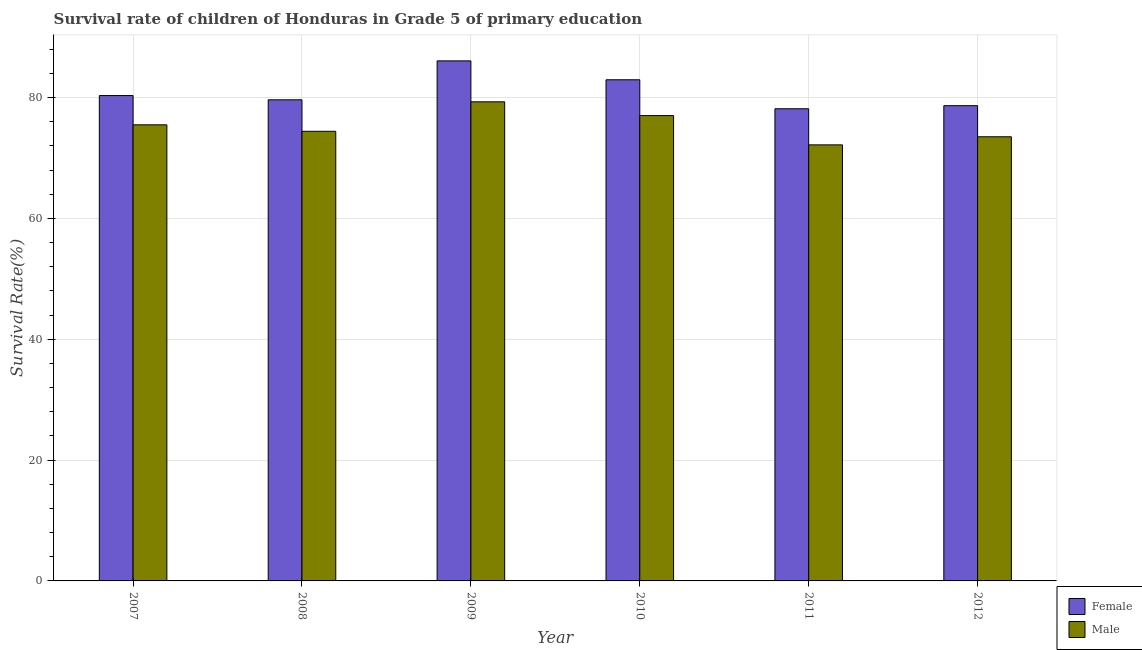What is the survival rate of male students in primary education in 2007?
Make the answer very short. 75.49. Across all years, what is the maximum survival rate of male students in primary education?
Ensure brevity in your answer.  79.3. Across all years, what is the minimum survival rate of male students in primary education?
Keep it short and to the point. 72.17. In which year was the survival rate of female students in primary education minimum?
Give a very brief answer. 2011. What is the total survival rate of male students in primary education in the graph?
Ensure brevity in your answer.  451.92. What is the difference between the survival rate of male students in primary education in 2007 and that in 2012?
Offer a terse response. 1.98. What is the difference between the survival rate of male students in primary education in 2011 and the survival rate of female students in primary education in 2008?
Ensure brevity in your answer.  -2.24. What is the average survival rate of male students in primary education per year?
Keep it short and to the point. 75.32. In the year 2007, what is the difference between the survival rate of male students in primary education and survival rate of female students in primary education?
Ensure brevity in your answer.  0. In how many years, is the survival rate of male students in primary education greater than 32 %?
Provide a succinct answer. 6. What is the ratio of the survival rate of female students in primary education in 2008 to that in 2012?
Ensure brevity in your answer.  1.01. Is the difference between the survival rate of female students in primary education in 2007 and 2009 greater than the difference between the survival rate of male students in primary education in 2007 and 2009?
Provide a short and direct response. No. What is the difference between the highest and the second highest survival rate of female students in primary education?
Give a very brief answer. 3.13. What is the difference between the highest and the lowest survival rate of female students in primary education?
Provide a short and direct response. 7.93. Is the sum of the survival rate of male students in primary education in 2007 and 2010 greater than the maximum survival rate of female students in primary education across all years?
Offer a very short reply. Yes. How many bars are there?
Keep it short and to the point. 12. Are all the bars in the graph horizontal?
Your answer should be compact. No. How many years are there in the graph?
Offer a terse response. 6. Does the graph contain any zero values?
Keep it short and to the point. No. How many legend labels are there?
Offer a terse response. 2. How are the legend labels stacked?
Your answer should be compact. Vertical. What is the title of the graph?
Keep it short and to the point. Survival rate of children of Honduras in Grade 5 of primary education. Does "From production" appear as one of the legend labels in the graph?
Give a very brief answer. No. What is the label or title of the X-axis?
Offer a very short reply. Year. What is the label or title of the Y-axis?
Give a very brief answer. Survival Rate(%). What is the Survival Rate(%) of Female in 2007?
Your answer should be very brief. 80.34. What is the Survival Rate(%) in Male in 2007?
Make the answer very short. 75.49. What is the Survival Rate(%) in Female in 2008?
Your answer should be compact. 79.63. What is the Survival Rate(%) in Male in 2008?
Keep it short and to the point. 74.42. What is the Survival Rate(%) of Female in 2009?
Your response must be concise. 86.08. What is the Survival Rate(%) in Male in 2009?
Ensure brevity in your answer.  79.3. What is the Survival Rate(%) of Female in 2010?
Offer a terse response. 82.95. What is the Survival Rate(%) of Male in 2010?
Give a very brief answer. 77.02. What is the Survival Rate(%) in Female in 2011?
Keep it short and to the point. 78.15. What is the Survival Rate(%) of Male in 2011?
Keep it short and to the point. 72.17. What is the Survival Rate(%) in Female in 2012?
Ensure brevity in your answer.  78.66. What is the Survival Rate(%) of Male in 2012?
Offer a very short reply. 73.51. Across all years, what is the maximum Survival Rate(%) in Female?
Offer a very short reply. 86.08. Across all years, what is the maximum Survival Rate(%) in Male?
Give a very brief answer. 79.3. Across all years, what is the minimum Survival Rate(%) in Female?
Ensure brevity in your answer.  78.15. Across all years, what is the minimum Survival Rate(%) in Male?
Your answer should be compact. 72.17. What is the total Survival Rate(%) of Female in the graph?
Provide a succinct answer. 485.8. What is the total Survival Rate(%) in Male in the graph?
Give a very brief answer. 451.92. What is the difference between the Survival Rate(%) of Female in 2007 and that in 2008?
Provide a succinct answer. 0.71. What is the difference between the Survival Rate(%) of Male in 2007 and that in 2008?
Provide a short and direct response. 1.07. What is the difference between the Survival Rate(%) of Female in 2007 and that in 2009?
Give a very brief answer. -5.74. What is the difference between the Survival Rate(%) of Male in 2007 and that in 2009?
Provide a short and direct response. -3.81. What is the difference between the Survival Rate(%) in Female in 2007 and that in 2010?
Make the answer very short. -2.61. What is the difference between the Survival Rate(%) in Male in 2007 and that in 2010?
Offer a terse response. -1.53. What is the difference between the Survival Rate(%) of Female in 2007 and that in 2011?
Your answer should be compact. 2.19. What is the difference between the Survival Rate(%) of Male in 2007 and that in 2011?
Ensure brevity in your answer.  3.32. What is the difference between the Survival Rate(%) of Female in 2007 and that in 2012?
Provide a succinct answer. 1.68. What is the difference between the Survival Rate(%) of Male in 2007 and that in 2012?
Your response must be concise. 1.98. What is the difference between the Survival Rate(%) in Female in 2008 and that in 2009?
Your answer should be very brief. -6.44. What is the difference between the Survival Rate(%) in Male in 2008 and that in 2009?
Provide a short and direct response. -4.88. What is the difference between the Survival Rate(%) in Female in 2008 and that in 2010?
Provide a succinct answer. -3.32. What is the difference between the Survival Rate(%) of Male in 2008 and that in 2010?
Make the answer very short. -2.6. What is the difference between the Survival Rate(%) of Female in 2008 and that in 2011?
Give a very brief answer. 1.48. What is the difference between the Survival Rate(%) in Male in 2008 and that in 2011?
Your answer should be very brief. 2.24. What is the difference between the Survival Rate(%) in Female in 2008 and that in 2012?
Provide a succinct answer. 0.97. What is the difference between the Survival Rate(%) in Male in 2008 and that in 2012?
Keep it short and to the point. 0.9. What is the difference between the Survival Rate(%) in Female in 2009 and that in 2010?
Offer a terse response. 3.13. What is the difference between the Survival Rate(%) in Male in 2009 and that in 2010?
Keep it short and to the point. 2.28. What is the difference between the Survival Rate(%) of Female in 2009 and that in 2011?
Your answer should be very brief. 7.93. What is the difference between the Survival Rate(%) in Male in 2009 and that in 2011?
Your answer should be compact. 7.13. What is the difference between the Survival Rate(%) of Female in 2009 and that in 2012?
Offer a terse response. 7.42. What is the difference between the Survival Rate(%) in Male in 2009 and that in 2012?
Make the answer very short. 5.79. What is the difference between the Survival Rate(%) in Female in 2010 and that in 2011?
Make the answer very short. 4.8. What is the difference between the Survival Rate(%) of Male in 2010 and that in 2011?
Your response must be concise. 4.85. What is the difference between the Survival Rate(%) in Female in 2010 and that in 2012?
Provide a short and direct response. 4.29. What is the difference between the Survival Rate(%) of Male in 2010 and that in 2012?
Offer a terse response. 3.51. What is the difference between the Survival Rate(%) in Female in 2011 and that in 2012?
Your answer should be compact. -0.51. What is the difference between the Survival Rate(%) in Male in 2011 and that in 2012?
Keep it short and to the point. -1.34. What is the difference between the Survival Rate(%) of Female in 2007 and the Survival Rate(%) of Male in 2008?
Provide a short and direct response. 5.92. What is the difference between the Survival Rate(%) in Female in 2007 and the Survival Rate(%) in Male in 2009?
Your response must be concise. 1.04. What is the difference between the Survival Rate(%) in Female in 2007 and the Survival Rate(%) in Male in 2010?
Offer a very short reply. 3.32. What is the difference between the Survival Rate(%) in Female in 2007 and the Survival Rate(%) in Male in 2011?
Keep it short and to the point. 8.16. What is the difference between the Survival Rate(%) in Female in 2007 and the Survival Rate(%) in Male in 2012?
Provide a succinct answer. 6.82. What is the difference between the Survival Rate(%) of Female in 2008 and the Survival Rate(%) of Male in 2009?
Keep it short and to the point. 0.33. What is the difference between the Survival Rate(%) in Female in 2008 and the Survival Rate(%) in Male in 2010?
Your response must be concise. 2.61. What is the difference between the Survival Rate(%) of Female in 2008 and the Survival Rate(%) of Male in 2011?
Keep it short and to the point. 7.46. What is the difference between the Survival Rate(%) in Female in 2008 and the Survival Rate(%) in Male in 2012?
Make the answer very short. 6.12. What is the difference between the Survival Rate(%) of Female in 2009 and the Survival Rate(%) of Male in 2010?
Provide a short and direct response. 9.06. What is the difference between the Survival Rate(%) in Female in 2009 and the Survival Rate(%) in Male in 2011?
Your response must be concise. 13.9. What is the difference between the Survival Rate(%) in Female in 2009 and the Survival Rate(%) in Male in 2012?
Ensure brevity in your answer.  12.56. What is the difference between the Survival Rate(%) in Female in 2010 and the Survival Rate(%) in Male in 2011?
Offer a very short reply. 10.78. What is the difference between the Survival Rate(%) in Female in 2010 and the Survival Rate(%) in Male in 2012?
Give a very brief answer. 9.44. What is the difference between the Survival Rate(%) of Female in 2011 and the Survival Rate(%) of Male in 2012?
Provide a short and direct response. 4.64. What is the average Survival Rate(%) in Female per year?
Ensure brevity in your answer.  80.97. What is the average Survival Rate(%) in Male per year?
Your response must be concise. 75.32. In the year 2007, what is the difference between the Survival Rate(%) of Female and Survival Rate(%) of Male?
Ensure brevity in your answer.  4.84. In the year 2008, what is the difference between the Survival Rate(%) of Female and Survival Rate(%) of Male?
Provide a succinct answer. 5.21. In the year 2009, what is the difference between the Survival Rate(%) of Female and Survival Rate(%) of Male?
Provide a short and direct response. 6.77. In the year 2010, what is the difference between the Survival Rate(%) of Female and Survival Rate(%) of Male?
Give a very brief answer. 5.93. In the year 2011, what is the difference between the Survival Rate(%) in Female and Survival Rate(%) in Male?
Your answer should be very brief. 5.98. In the year 2012, what is the difference between the Survival Rate(%) in Female and Survival Rate(%) in Male?
Give a very brief answer. 5.15. What is the ratio of the Survival Rate(%) of Female in 2007 to that in 2008?
Your answer should be very brief. 1.01. What is the ratio of the Survival Rate(%) in Male in 2007 to that in 2008?
Give a very brief answer. 1.01. What is the ratio of the Survival Rate(%) in Female in 2007 to that in 2009?
Provide a short and direct response. 0.93. What is the ratio of the Survival Rate(%) of Female in 2007 to that in 2010?
Give a very brief answer. 0.97. What is the ratio of the Survival Rate(%) in Male in 2007 to that in 2010?
Ensure brevity in your answer.  0.98. What is the ratio of the Survival Rate(%) of Female in 2007 to that in 2011?
Ensure brevity in your answer.  1.03. What is the ratio of the Survival Rate(%) in Male in 2007 to that in 2011?
Your response must be concise. 1.05. What is the ratio of the Survival Rate(%) of Female in 2007 to that in 2012?
Provide a short and direct response. 1.02. What is the ratio of the Survival Rate(%) of Male in 2007 to that in 2012?
Your response must be concise. 1.03. What is the ratio of the Survival Rate(%) of Female in 2008 to that in 2009?
Give a very brief answer. 0.93. What is the ratio of the Survival Rate(%) of Male in 2008 to that in 2009?
Offer a terse response. 0.94. What is the ratio of the Survival Rate(%) of Female in 2008 to that in 2010?
Offer a very short reply. 0.96. What is the ratio of the Survival Rate(%) in Male in 2008 to that in 2010?
Your answer should be very brief. 0.97. What is the ratio of the Survival Rate(%) of Male in 2008 to that in 2011?
Give a very brief answer. 1.03. What is the ratio of the Survival Rate(%) in Female in 2008 to that in 2012?
Provide a short and direct response. 1.01. What is the ratio of the Survival Rate(%) of Male in 2008 to that in 2012?
Offer a terse response. 1.01. What is the ratio of the Survival Rate(%) of Female in 2009 to that in 2010?
Offer a terse response. 1.04. What is the ratio of the Survival Rate(%) of Male in 2009 to that in 2010?
Your response must be concise. 1.03. What is the ratio of the Survival Rate(%) of Female in 2009 to that in 2011?
Your answer should be very brief. 1.1. What is the ratio of the Survival Rate(%) of Male in 2009 to that in 2011?
Offer a very short reply. 1.1. What is the ratio of the Survival Rate(%) of Female in 2009 to that in 2012?
Ensure brevity in your answer.  1.09. What is the ratio of the Survival Rate(%) in Male in 2009 to that in 2012?
Keep it short and to the point. 1.08. What is the ratio of the Survival Rate(%) in Female in 2010 to that in 2011?
Your response must be concise. 1.06. What is the ratio of the Survival Rate(%) of Male in 2010 to that in 2011?
Your response must be concise. 1.07. What is the ratio of the Survival Rate(%) of Female in 2010 to that in 2012?
Provide a short and direct response. 1.05. What is the ratio of the Survival Rate(%) of Male in 2010 to that in 2012?
Offer a very short reply. 1.05. What is the ratio of the Survival Rate(%) in Female in 2011 to that in 2012?
Your answer should be compact. 0.99. What is the ratio of the Survival Rate(%) in Male in 2011 to that in 2012?
Your answer should be very brief. 0.98. What is the difference between the highest and the second highest Survival Rate(%) of Female?
Keep it short and to the point. 3.13. What is the difference between the highest and the second highest Survival Rate(%) of Male?
Give a very brief answer. 2.28. What is the difference between the highest and the lowest Survival Rate(%) in Female?
Offer a very short reply. 7.93. What is the difference between the highest and the lowest Survival Rate(%) in Male?
Ensure brevity in your answer.  7.13. 